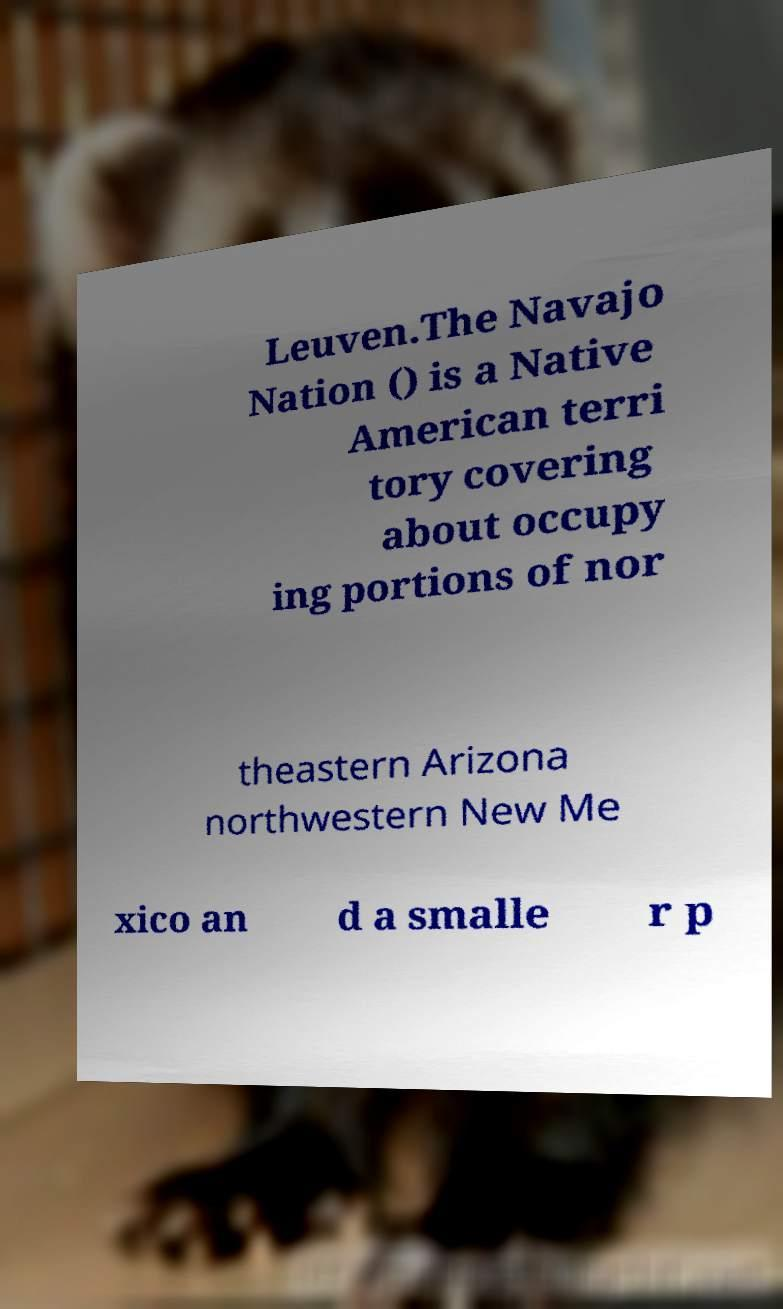I need the written content from this picture converted into text. Can you do that? Leuven.The Navajo Nation () is a Native American terri tory covering about occupy ing portions of nor theastern Arizona northwestern New Me xico an d a smalle r p 